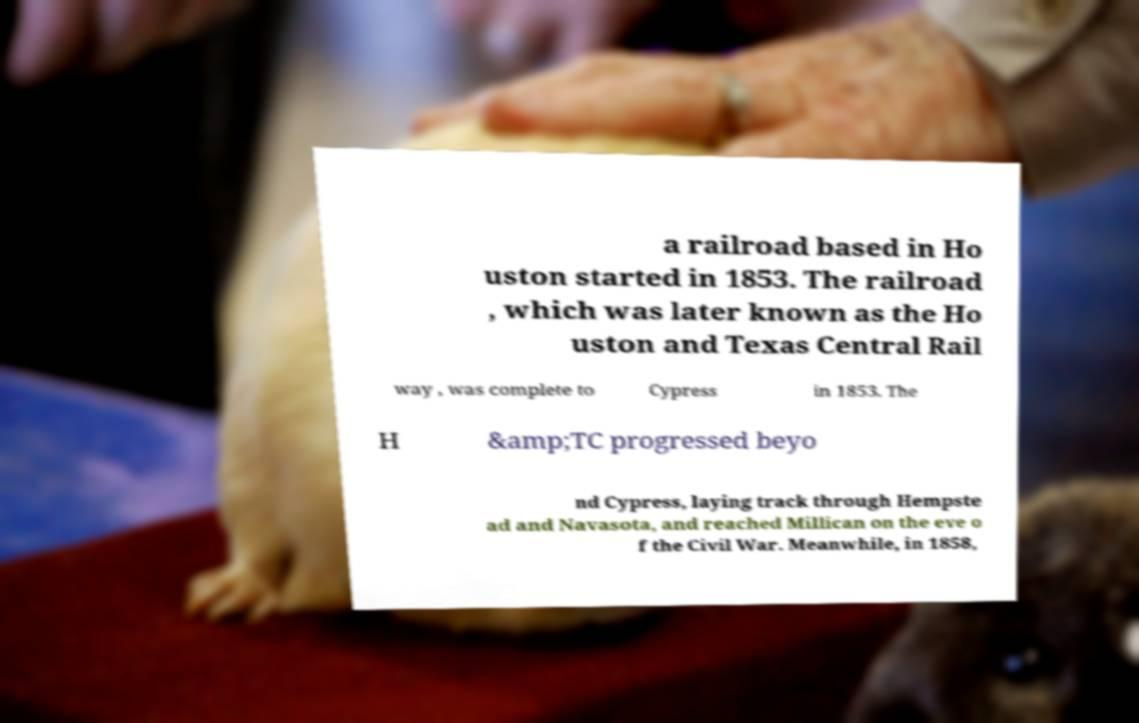Could you extract and type out the text from this image? a railroad based in Ho uston started in 1853. The railroad , which was later known as the Ho uston and Texas Central Rail way , was complete to Cypress in 1853. The H &amp;TC progressed beyo nd Cypress, laying track through Hempste ad and Navasota, and reached Millican on the eve o f the Civil War. Meanwhile, in 1858, 